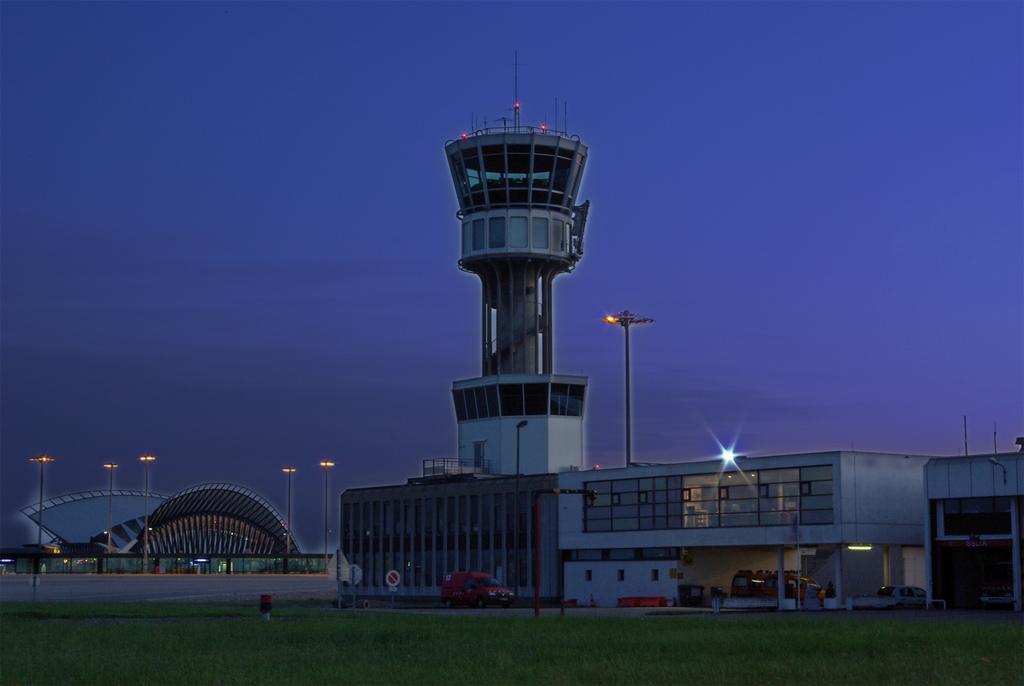How would you summarize this image in a sentence or two? In this picture we can observe some grass on the ground. There is a building and a tower. We can observe a vehicle here. In the background there are poles and a sky. 